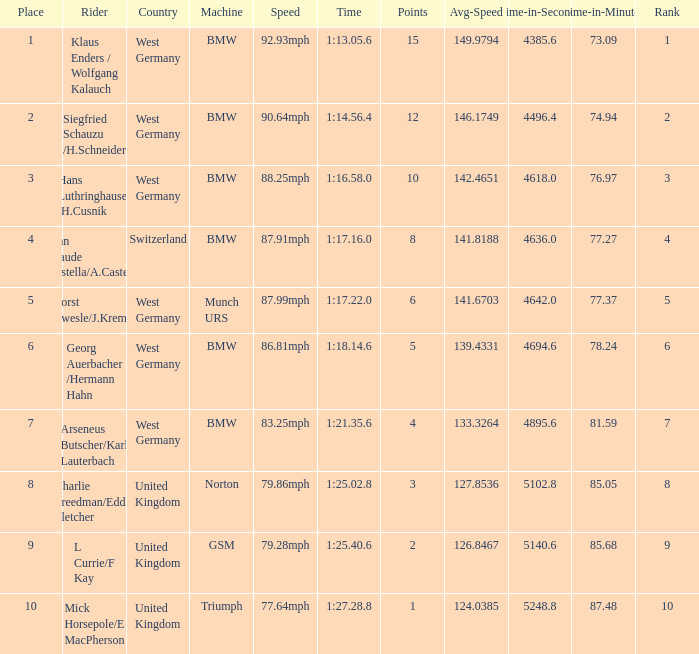Which places have points larger than 10? None. 